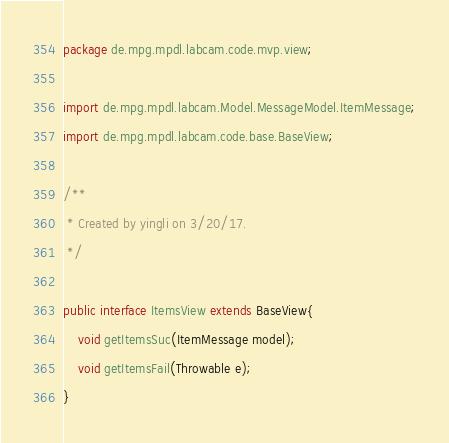Convert code to text. <code><loc_0><loc_0><loc_500><loc_500><_Java_>package de.mpg.mpdl.labcam.code.mvp.view;

import de.mpg.mpdl.labcam.Model.MessageModel.ItemMessage;
import de.mpg.mpdl.labcam.code.base.BaseView;

/**
 * Created by yingli on 3/20/17.
 */

public interface ItemsView extends BaseView{
    void getItemsSuc(ItemMessage model);
    void getItemsFail(Throwable e);
}
</code> 